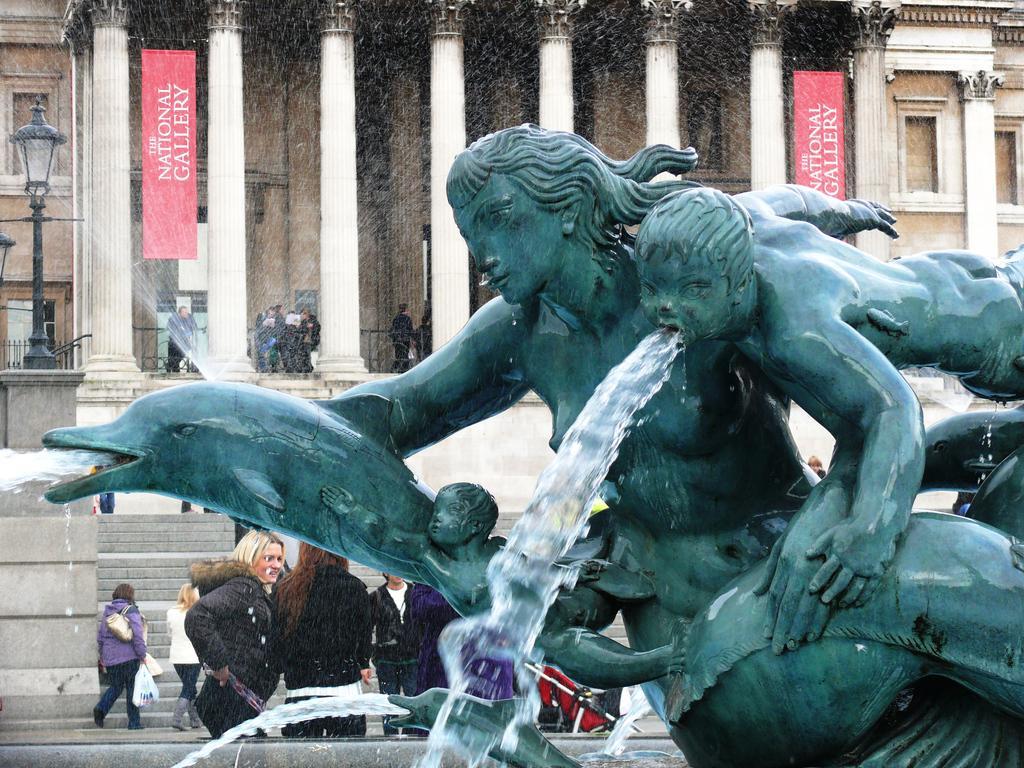Describe this image in one or two sentences. In this image I can see a statue which is green in color and water coming from the statue. In the background I can see few pillars, few persons, few boards and few buildings. 